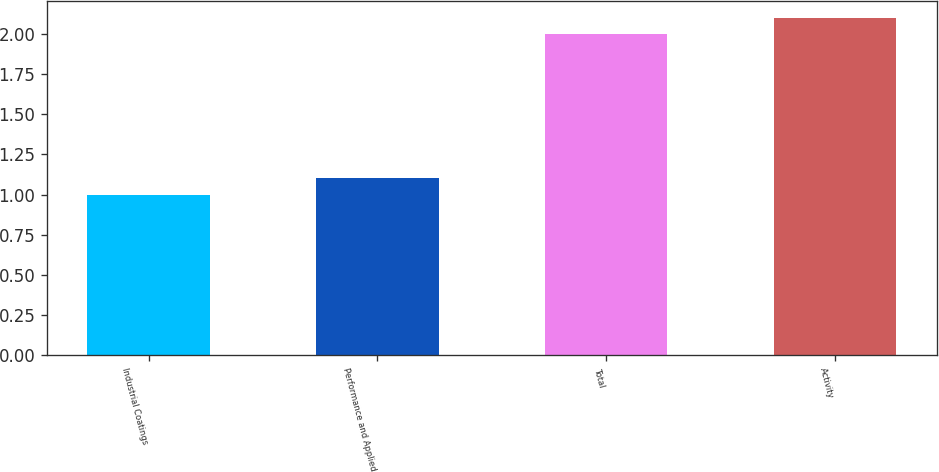Convert chart. <chart><loc_0><loc_0><loc_500><loc_500><bar_chart><fcel>Industrial Coatings<fcel>Performance and Applied<fcel>Total<fcel>Activity<nl><fcel>1<fcel>1.1<fcel>2<fcel>2.1<nl></chart> 